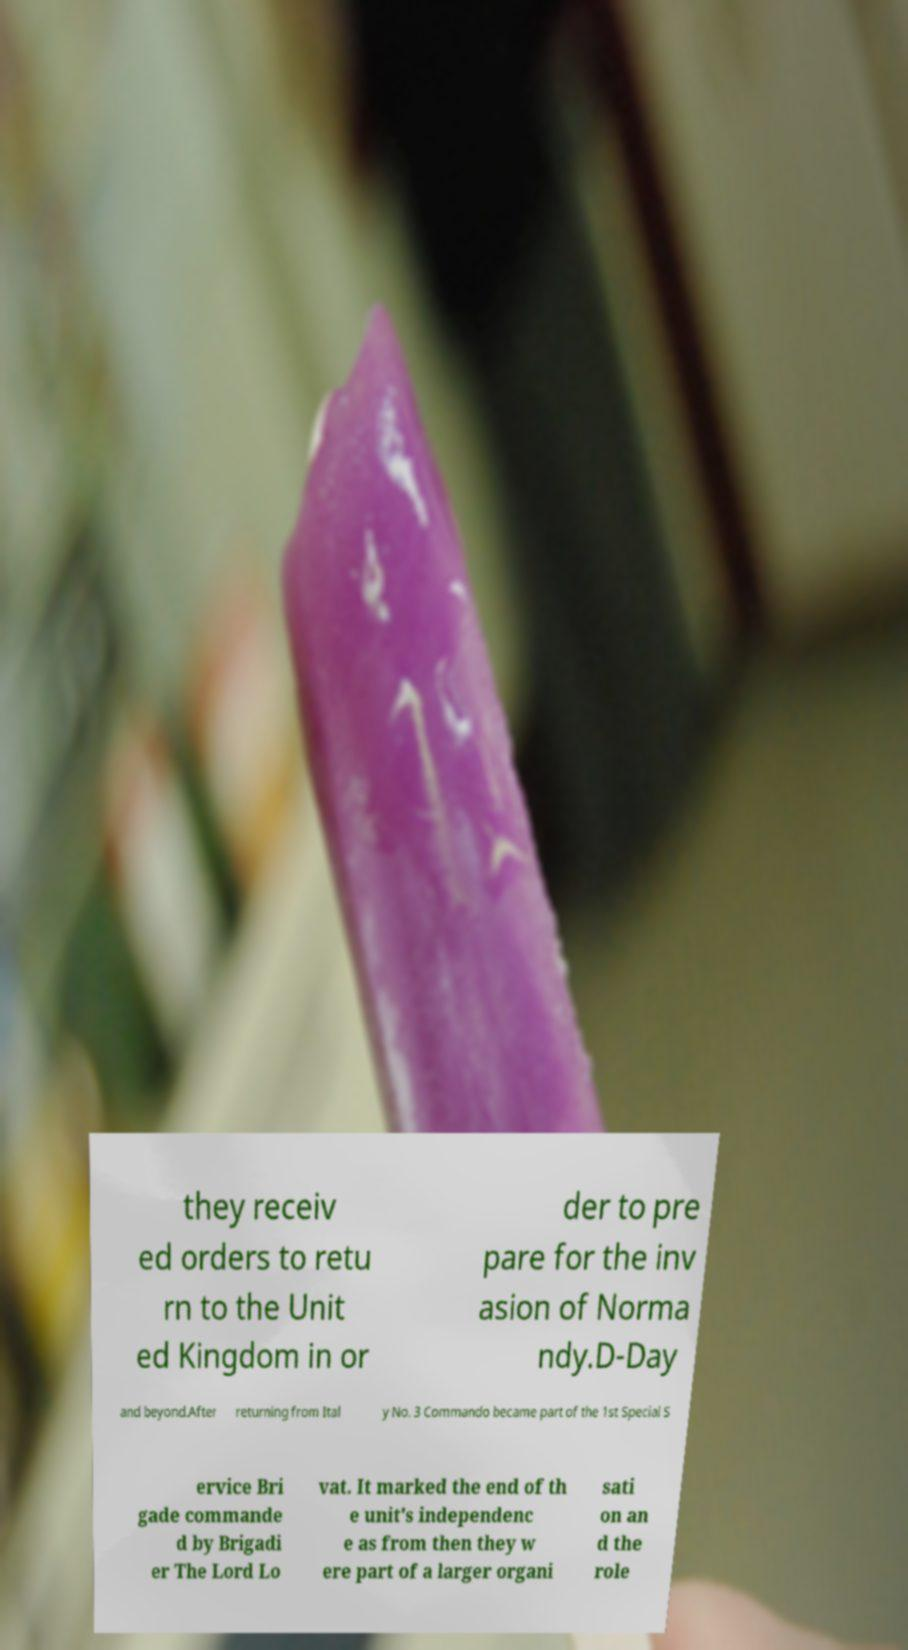Could you extract and type out the text from this image? they receiv ed orders to retu rn to the Unit ed Kingdom in or der to pre pare for the inv asion of Norma ndy.D-Day and beyond.After returning from Ital y No. 3 Commando became part of the 1st Special S ervice Bri gade commande d by Brigadi er The Lord Lo vat. It marked the end of th e unit's independenc e as from then they w ere part of a larger organi sati on an d the role 